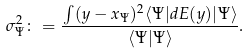Convert formula to latex. <formula><loc_0><loc_0><loc_500><loc_500>\sigma ^ { 2 } _ { \Psi } \colon = \frac { \int ( { y } - { x } _ { \Psi } ) ^ { 2 } \langle \Psi | d E ( { y } ) | \Psi \rangle } { \langle \Psi | \Psi \rangle } .</formula> 